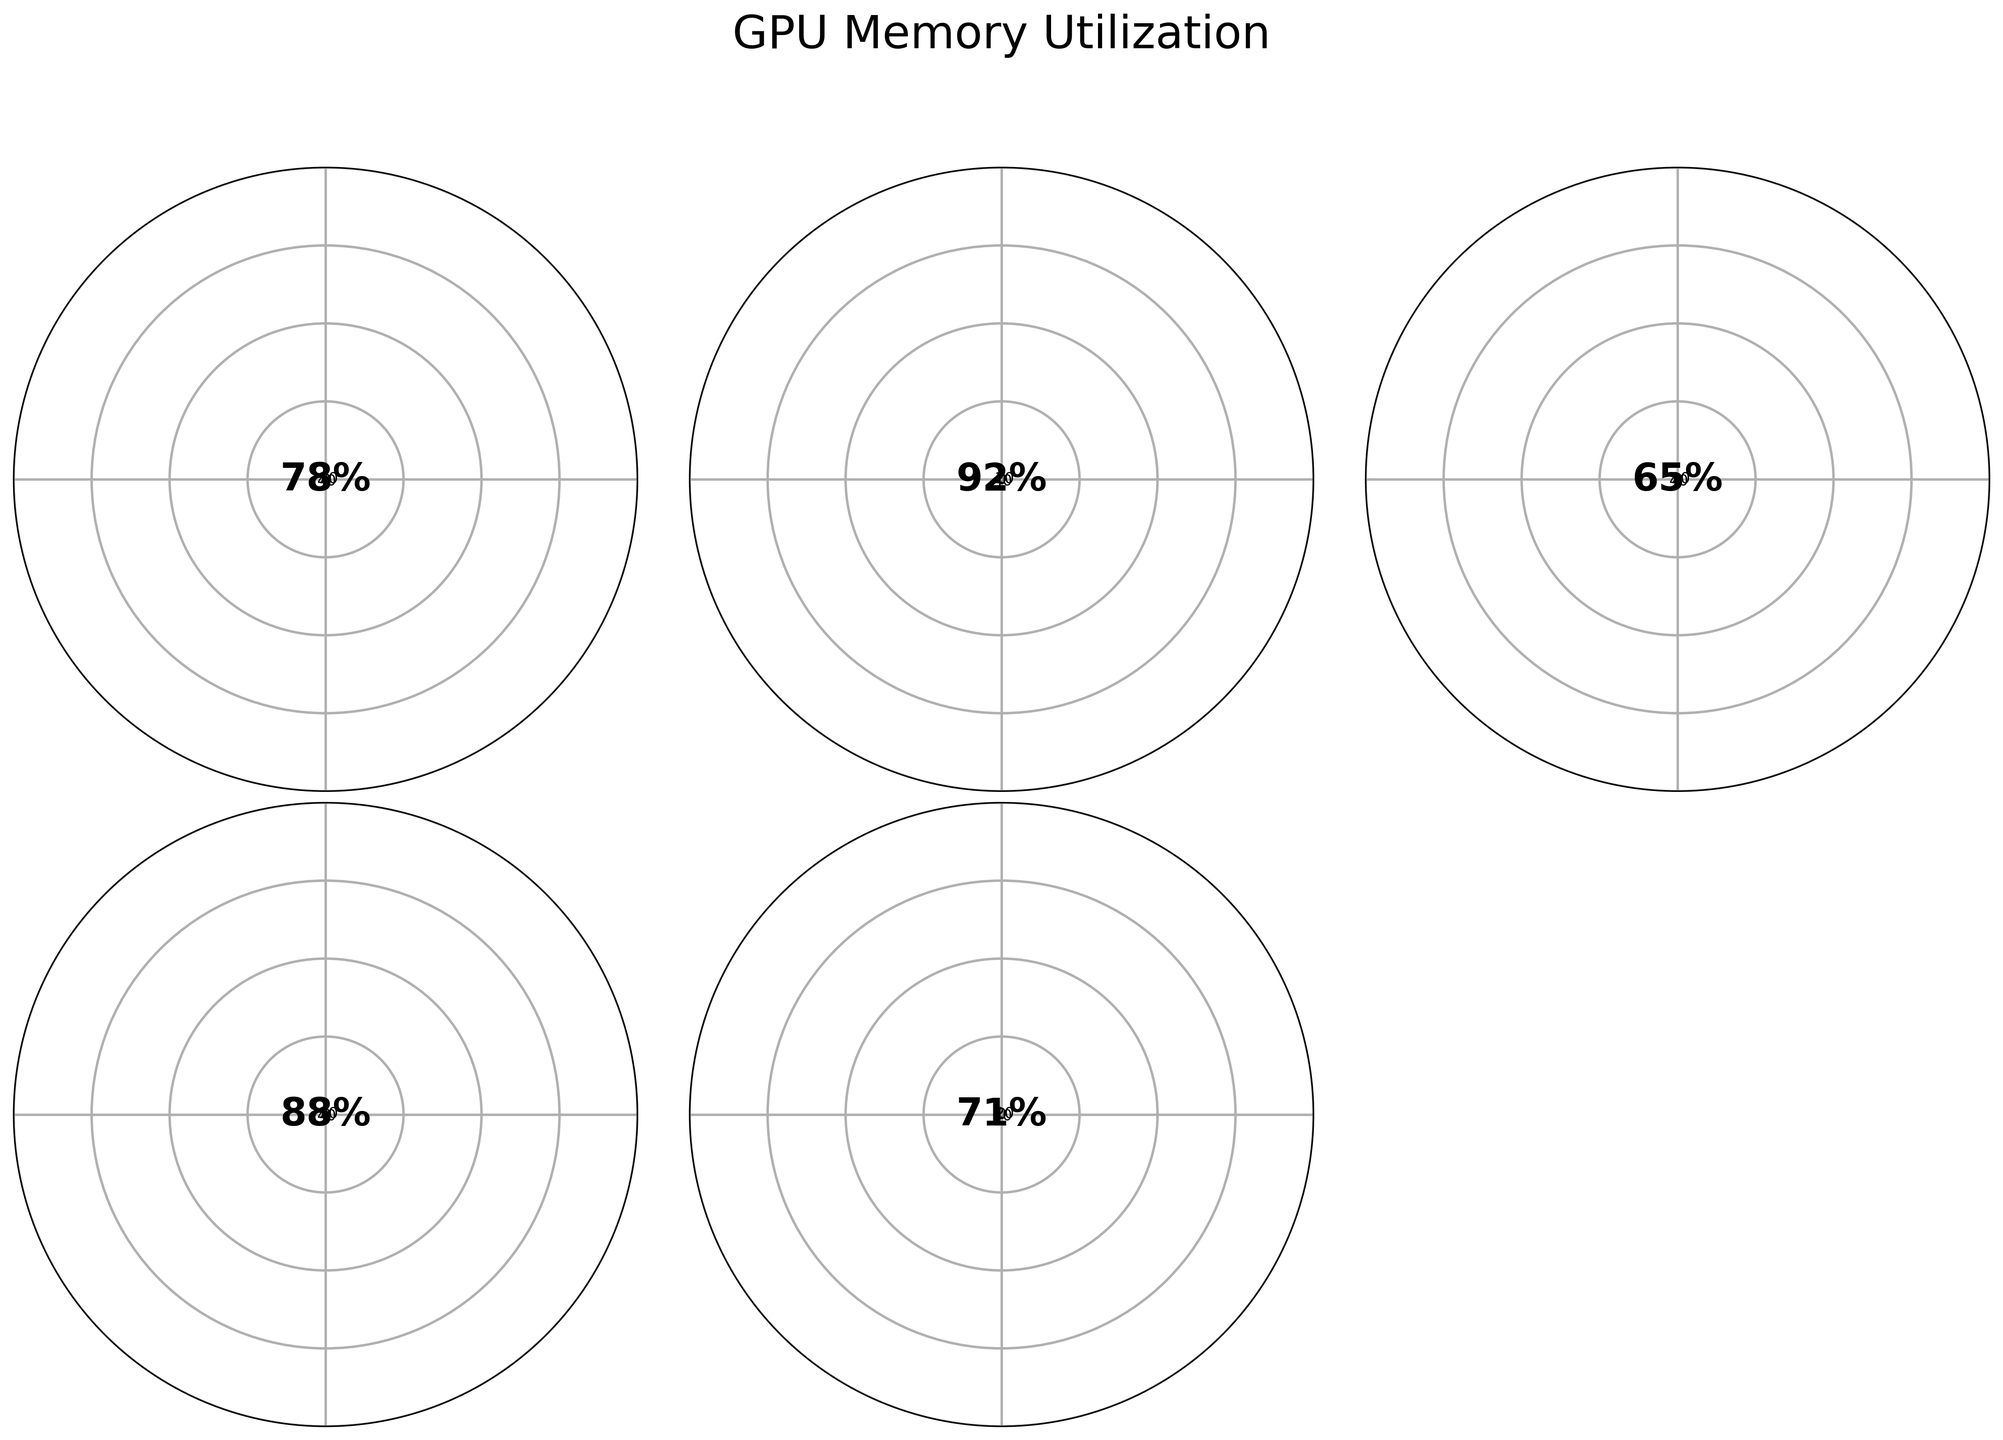What is the title of the plot? The title is displayed at the top center of the plot and it is "GPU Memory Utilization".
Answer: GPU Memory Utilization Which GPU model has the highest memory utilization? The highest percentage gauge is filled for the GPU with 92%, which is labeled as "NVIDIA Tesla T4".
Answer: NVIDIA Tesla T4 How many GPUs are displayed in the plot? The plot consists of 5 gauge charts, each representing a different GPU model.
Answer: 5 What is the memory utilization percentage of the NVIDIA GeForce RTX 3060? The gauge chart for the NVIDIA GeForce RTX 3060 shows a memory utilization of 78%.
Answer: 78% Which GPU model has the lowest memory utilization? The gauge chart with the lowest fill percentage represents the GPU with 65%, labeled as "AMD Radeon RX 6700 XT".
Answer: AMD Radeon RX 6700 XT What is the difference in memory utilization between the NVIDIA GeForce GTX 1660 Ti and the NVIDIA Quadro RTX 4000? The memory utilization for the NVIDIA GeForce GTX 1660 Ti is 88%, and for the NVIDIA Quadro RTX 4000, it is 71%. The difference is 88% - 71% = 17%.
Answer: 17% What is the average memory utilization percentage of all the GPUs? The memory utilization percentages are: 78, 92, 65, 88, and 71. The sum is 394, and the average is 394/5 = 78.8%.
Answer: 78.8% Compare the memory utilization of NVIDIA GeForce RTX 3060 and AMD Radeon RX 6700 XT. Which one has higher utilization? The memory utilization for the NVIDIA GeForce RTX 3060 is 78%, which is higher than the AMD Radeon RX 6700 XT's 65%.
Answer: NVIDIA GeForce RTX 3060 Are there any memory utilizations below 70%? Yes, the gauge connected to "AMD Radeon RX 6700 XT" shows 65% utilization, which is below 70%.
Answer: Yes 